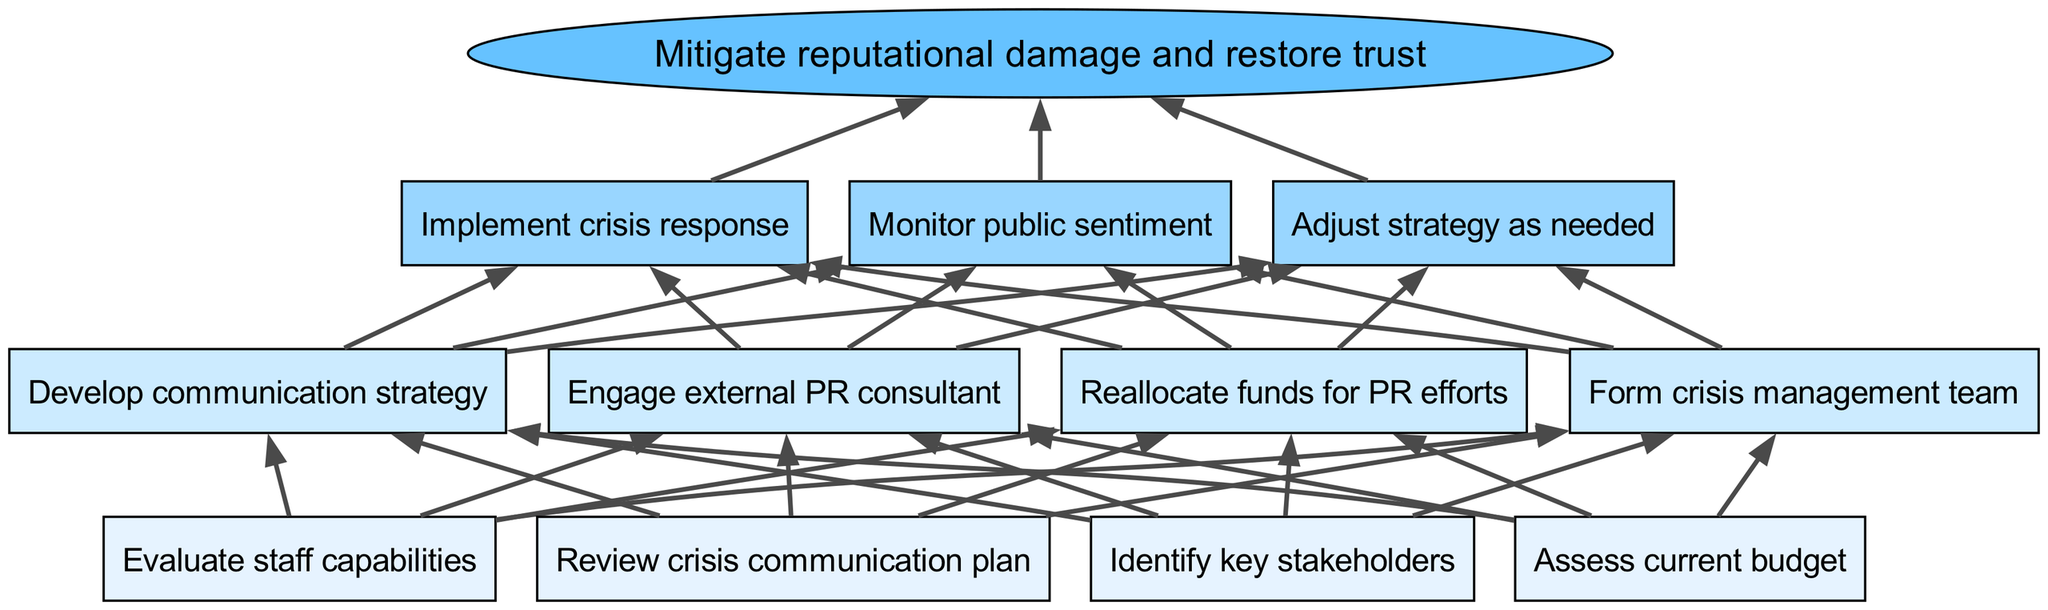What are the key stakeholders mentioned in the bottom level? The key stakeholders are listed in the "bottom_level" category of the diagram, which includes "Identify key stakeholders".
Answer: Identify key stakeholders How many nodes are there in the middle level? The middle level comprises the items listed under "middle_level", which includes four distinct elements.
Answer: 4 Which node leads to "Develop communication strategy"? Tracing the arrows in the diagram, "Develop communication strategy" is the third item in the middle level, receiving inputs from "Assess current budget" and "Evaluate staff capabilities".
Answer: Form crisis management team What is the final outcome of the diagram? The final outcome node is represented at the bottom of the diagram, which captures the end result of the processes described above. It is explicitly stated as "Mitigate reputational damage and restore trust".
Answer: Mitigate reputational damage and restore trust How many edges lead away from the top level? Each node in the top level connects to the final outcome node, with three nodes in the top level, thus there are three outgoing edges.
Answer: 3 What is the relationship between "Reallocate funds for PR efforts" and "Implement crisis response"? The "Reallocate funds for PR efforts" node in the middle level connects to multiple nodes in the top level, including "Implement crisis response". Hence, it directly contributes to implementing the crisis response.
Answer: Contributes to What processes occur before "Engage external PR consultant"? Looking at the flow in the diagram, "Engage external PR consultant" is at the middle level and requires the completion of at least "Assess current budget" and "Review crisis communication plan" in the bottom level before it can occur.
Answer: Assess current budget, Review crisis communication plan How many total levels are present in the diagram? The diagram consists of three distinct levels: the bottom level, the middle level, and the top level, plus the final outcome. Counting these gives a total of four levels.
Answer: 4 Which middle-level action is directly related to monitoring public sentiment? "Monitoring public sentiment" is part of the top level; however, looking back, it is informed by several middle-level actions that would involve gathering data from stakeholder engagement, but lacks a direct cited relationship in the given diagram.
Answer: None 